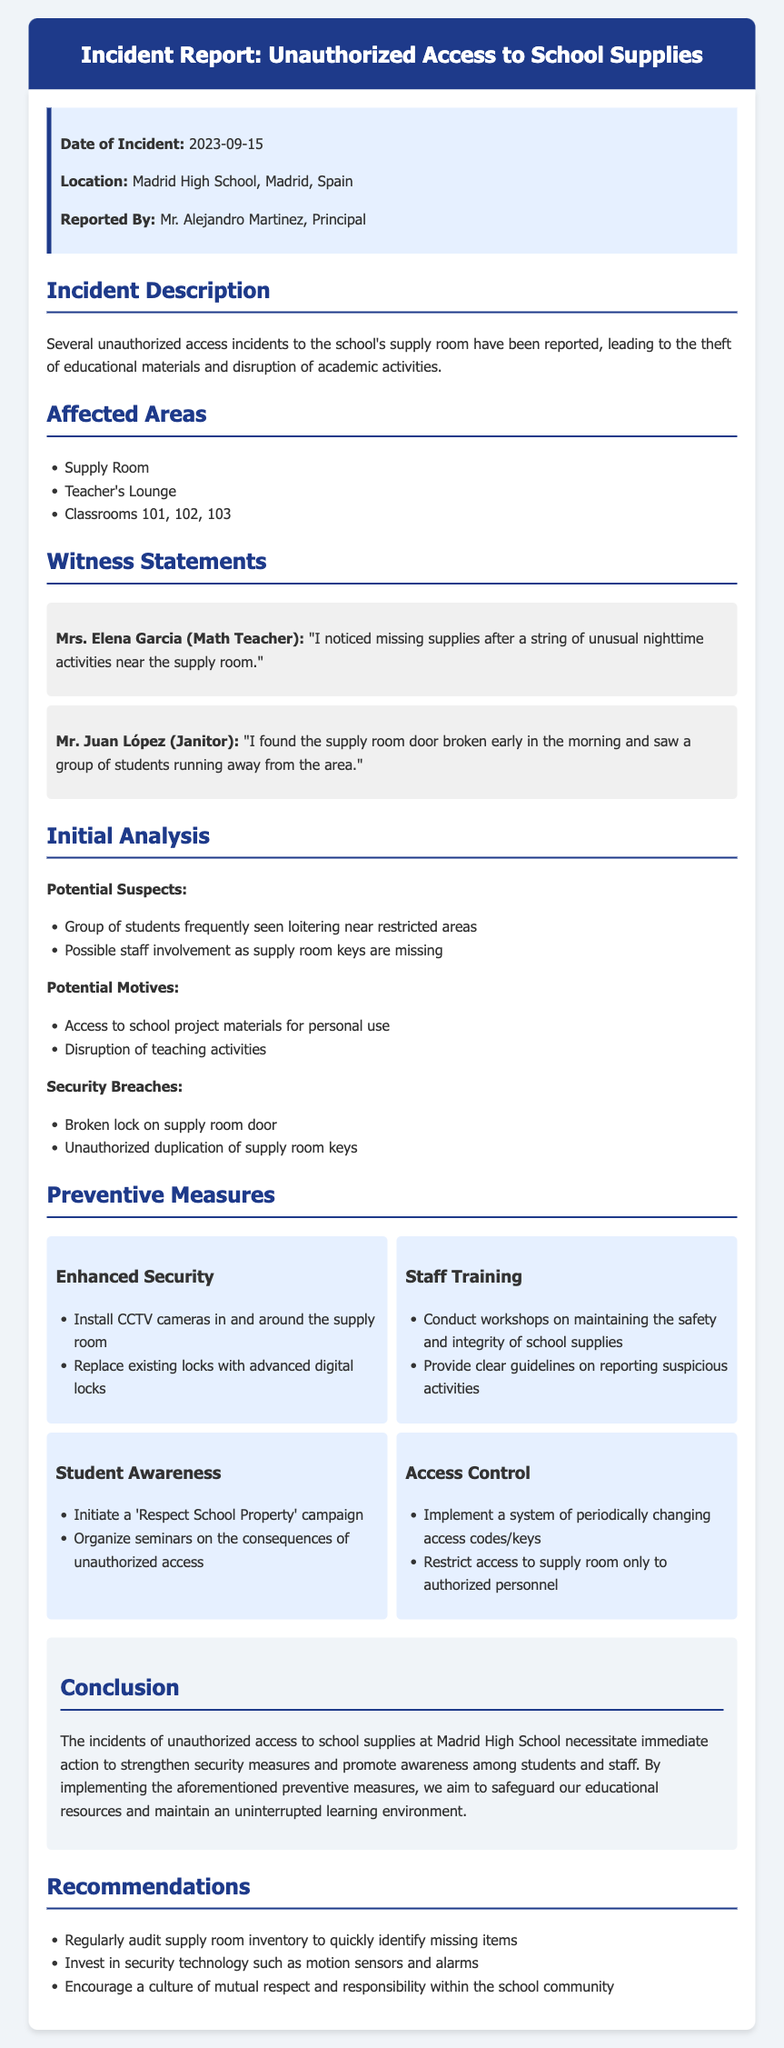What is the date of the incident? The date of the incident is stated clearly in the information box at the beginning of the document.
Answer: 2023-09-15 Who reported the incident? The report specifies the individual who reported the incident in the information box.
Answer: Mr. Alejandro Martinez What location did the incident occur? The specific location of the incident is mentioned in the same information box.
Answer: Madrid High School What were the affected areas? The affected areas are listed under a specific section titled "Affected Areas" in the document.
Answer: Supply Room, Teacher's Lounge, Classrooms 101, 102, 103 What is one potential motive for the unauthorized access? The potential motives are listed in the section called "Potential Motives" within the analysis.
Answer: Access to school project materials for personal use Who is the witness that mentioned unusual nighttime activities? One of the witness statements provides information about unusual activities related to the incident.
Answer: Mrs. Elena Garcia What security breach involved the supply room door? Specific security breaches are mentioned in the "Security Breaches" section of the analysis.
Answer: Broken lock on supply room door What measure involves staff training? The preventive measures list includes a specific item focused on staff training.
Answer: Conduct workshops on maintaining the safety and integrity of school supplies What is one recommendation made in the report? The recommendations section outlines suggestions for preventing future incidents.
Answer: Regularly audit supply room inventory to quickly identify missing items 